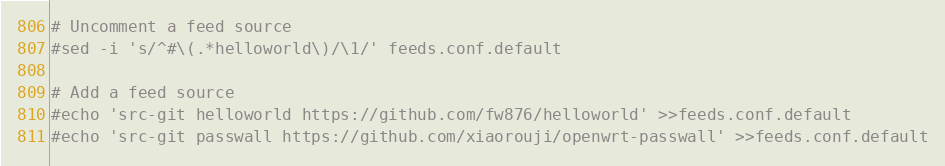Convert code to text. <code><loc_0><loc_0><loc_500><loc_500><_Bash_># Uncomment a feed source
#sed -i 's/^#\(.*helloworld\)/\1/' feeds.conf.default

# Add a feed source
#echo 'src-git helloworld https://github.com/fw876/helloworld' >>feeds.conf.default
#echo 'src-git passwall https://github.com/xiaorouji/openwrt-passwall' >>feeds.conf.default
</code> 